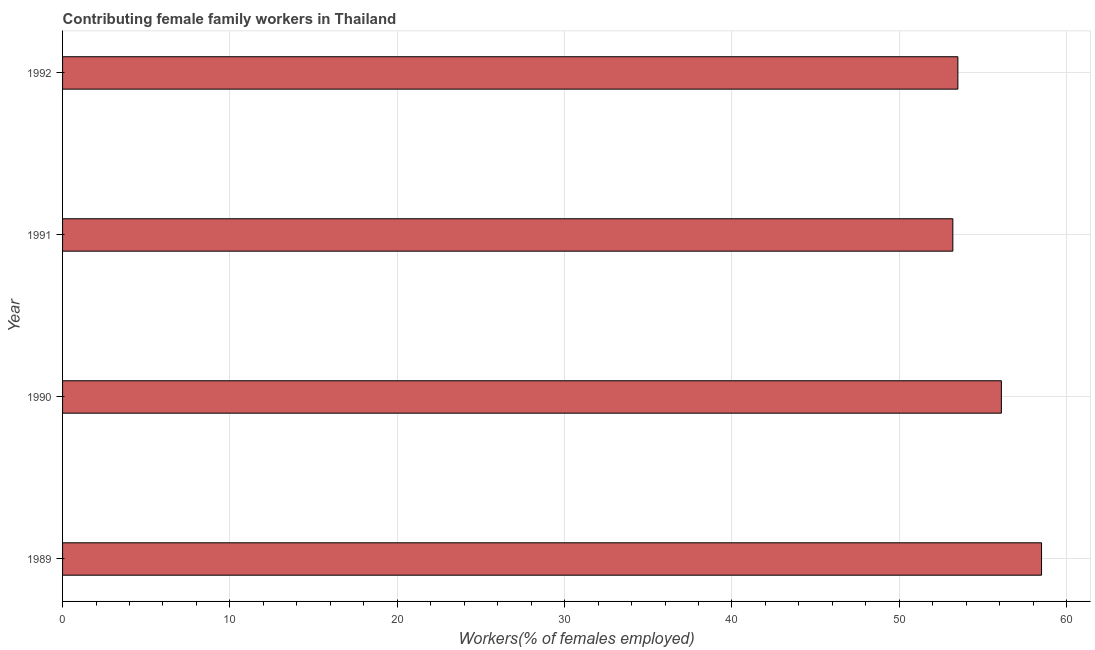What is the title of the graph?
Your response must be concise. Contributing female family workers in Thailand. What is the label or title of the X-axis?
Provide a short and direct response. Workers(% of females employed). What is the label or title of the Y-axis?
Your answer should be very brief. Year. What is the contributing female family workers in 1991?
Offer a very short reply. 53.2. Across all years, what is the maximum contributing female family workers?
Offer a terse response. 58.5. Across all years, what is the minimum contributing female family workers?
Provide a short and direct response. 53.2. What is the sum of the contributing female family workers?
Keep it short and to the point. 221.3. What is the difference between the contributing female family workers in 1990 and 1991?
Keep it short and to the point. 2.9. What is the average contributing female family workers per year?
Offer a very short reply. 55.33. What is the median contributing female family workers?
Your answer should be compact. 54.8. In how many years, is the contributing female family workers greater than 28 %?
Your answer should be very brief. 4. Do a majority of the years between 1992 and 1989 (inclusive) have contributing female family workers greater than 34 %?
Provide a short and direct response. Yes. What is the ratio of the contributing female family workers in 1990 to that in 1992?
Ensure brevity in your answer.  1.05. What is the difference between the highest and the second highest contributing female family workers?
Provide a succinct answer. 2.4. In how many years, is the contributing female family workers greater than the average contributing female family workers taken over all years?
Offer a terse response. 2. How many bars are there?
Provide a short and direct response. 4. Are all the bars in the graph horizontal?
Make the answer very short. Yes. How many years are there in the graph?
Your response must be concise. 4. What is the Workers(% of females employed) in 1989?
Your answer should be compact. 58.5. What is the Workers(% of females employed) of 1990?
Make the answer very short. 56.1. What is the Workers(% of females employed) of 1991?
Provide a succinct answer. 53.2. What is the Workers(% of females employed) of 1992?
Ensure brevity in your answer.  53.5. What is the difference between the Workers(% of females employed) in 1991 and 1992?
Your answer should be very brief. -0.3. What is the ratio of the Workers(% of females employed) in 1989 to that in 1990?
Your response must be concise. 1.04. What is the ratio of the Workers(% of females employed) in 1989 to that in 1992?
Offer a very short reply. 1.09. What is the ratio of the Workers(% of females employed) in 1990 to that in 1991?
Give a very brief answer. 1.05. What is the ratio of the Workers(% of females employed) in 1990 to that in 1992?
Provide a succinct answer. 1.05. 